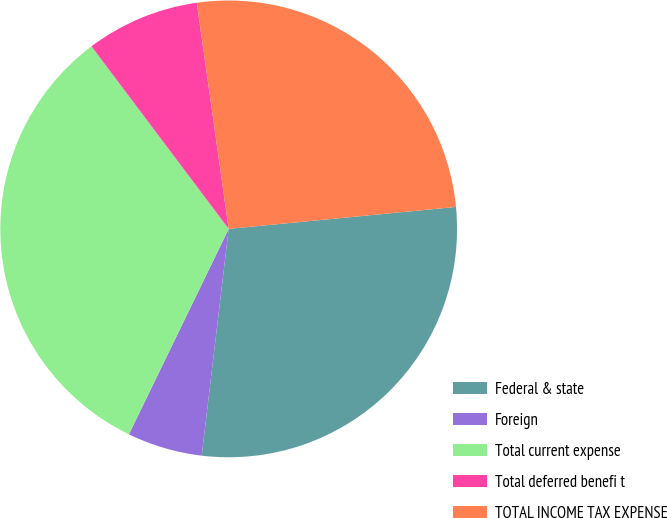<chart> <loc_0><loc_0><loc_500><loc_500><pie_chart><fcel>Federal & state<fcel>Foreign<fcel>Total current expense<fcel>Total deferred benefi t<fcel>TOTAL INCOME TAX EXPENSE<nl><fcel>28.42%<fcel>5.31%<fcel>32.55%<fcel>8.03%<fcel>25.7%<nl></chart> 